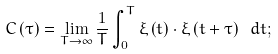<formula> <loc_0><loc_0><loc_500><loc_500>C \left ( \tau \right ) = \lim _ { T \rightarrow \infty } \frac { 1 } { T } \int ^ { T } _ { 0 } \xi \left ( t \right ) \cdot \xi \left ( t + \tau \right ) \ d t ;</formula> 